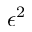Convert formula to latex. <formula><loc_0><loc_0><loc_500><loc_500>\epsilon ^ { 2 }</formula> 